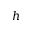<formula> <loc_0><loc_0><loc_500><loc_500>h</formula> 